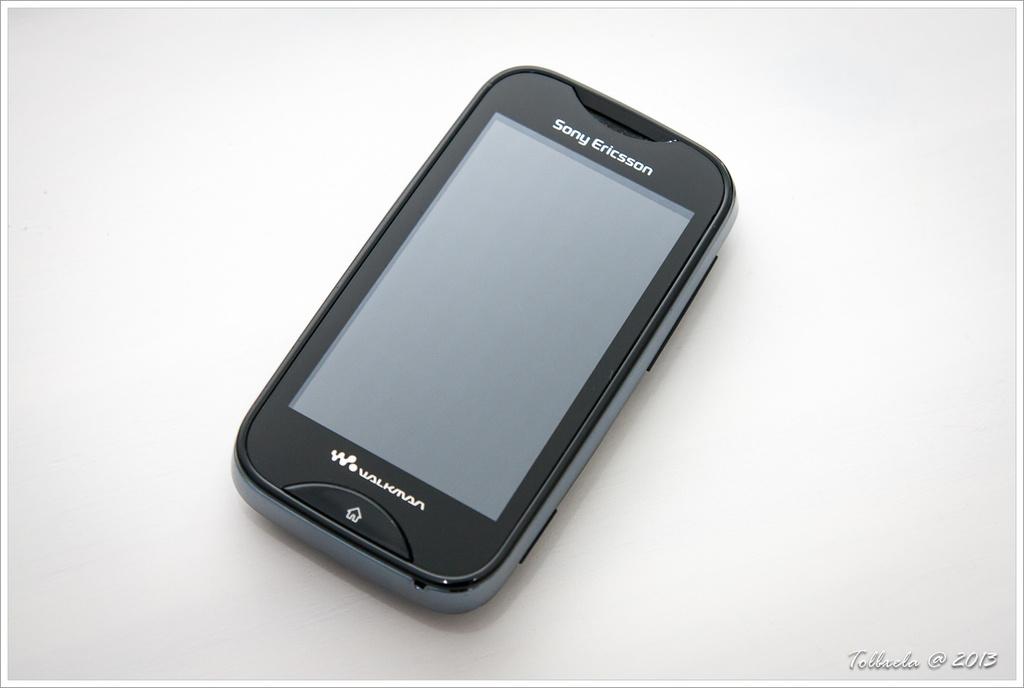What brand is the phone?
Offer a very short reply. Sony ericsson. 